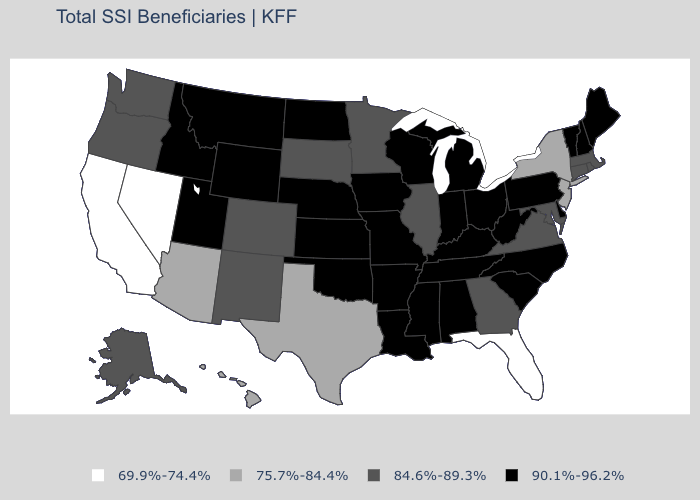What is the value of Mississippi?
Write a very short answer. 90.1%-96.2%. What is the value of Indiana?
Quick response, please. 90.1%-96.2%. What is the value of New Hampshire?
Write a very short answer. 90.1%-96.2%. What is the value of Minnesota?
Give a very brief answer. 84.6%-89.3%. What is the value of Maine?
Quick response, please. 90.1%-96.2%. Does the first symbol in the legend represent the smallest category?
Keep it brief. Yes. What is the lowest value in states that border Utah?
Quick response, please. 69.9%-74.4%. Which states have the highest value in the USA?
Answer briefly. Alabama, Arkansas, Delaware, Idaho, Indiana, Iowa, Kansas, Kentucky, Louisiana, Maine, Michigan, Mississippi, Missouri, Montana, Nebraska, New Hampshire, North Carolina, North Dakota, Ohio, Oklahoma, Pennsylvania, South Carolina, Tennessee, Utah, Vermont, West Virginia, Wisconsin, Wyoming. Name the states that have a value in the range 84.6%-89.3%?
Be succinct. Alaska, Colorado, Connecticut, Georgia, Illinois, Maryland, Massachusetts, Minnesota, New Mexico, Oregon, Rhode Island, South Dakota, Virginia, Washington. Name the states that have a value in the range 75.7%-84.4%?
Keep it brief. Arizona, Hawaii, New Jersey, New York, Texas. Does Iowa have the highest value in the USA?
Be succinct. Yes. Does New Jersey have the highest value in the USA?
Quick response, please. No. What is the lowest value in the USA?
Keep it brief. 69.9%-74.4%. What is the value of South Dakota?
Short answer required. 84.6%-89.3%. 